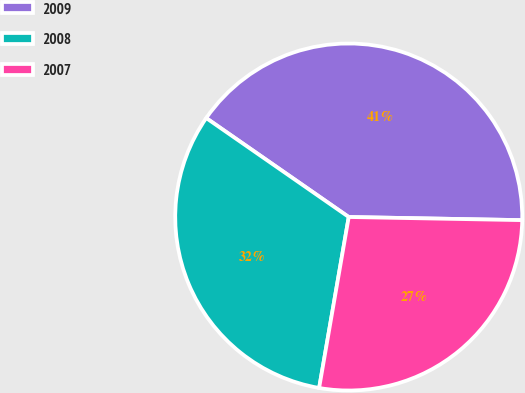<chart> <loc_0><loc_0><loc_500><loc_500><pie_chart><fcel>2009<fcel>2008<fcel>2007<nl><fcel>40.63%<fcel>31.93%<fcel>27.44%<nl></chart> 